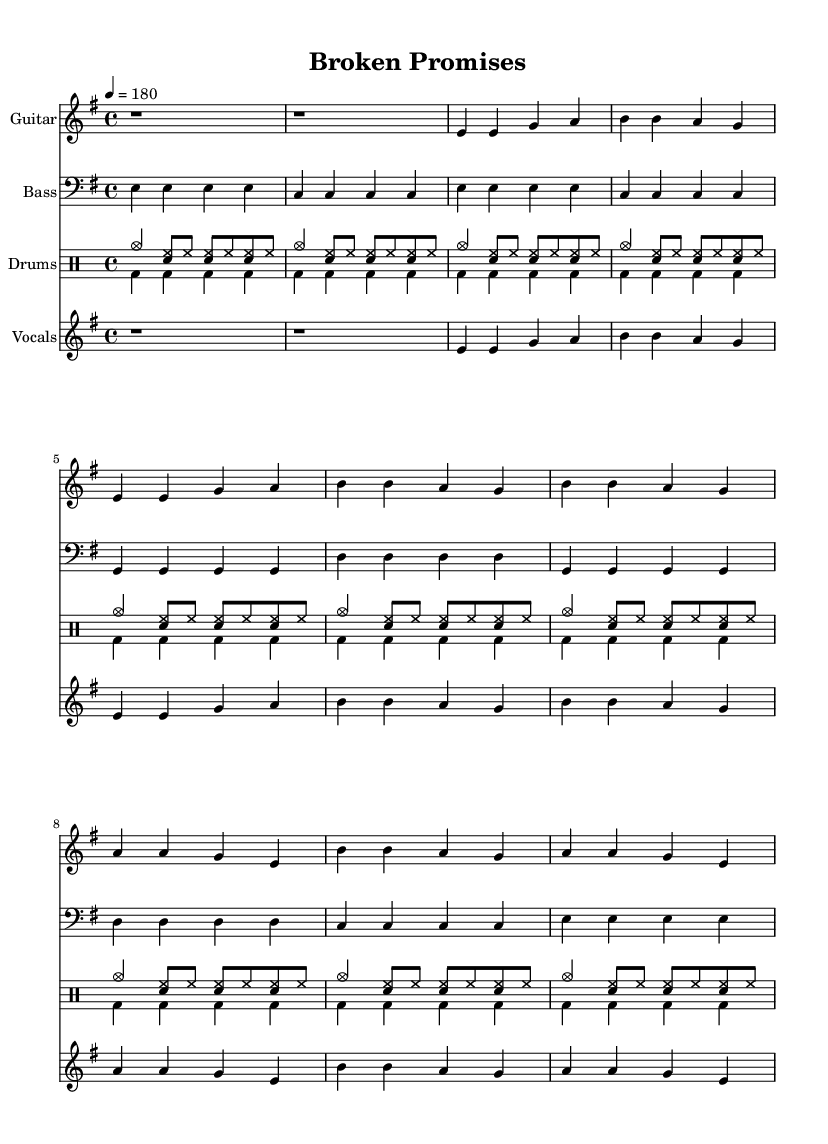What is the key signature of this music? The key signature is indicated at the beginning of the music. We see one sharp (F#), which means it's E minor (also known as G major, which has the same key signature).
Answer: E minor What is the time signature of the song? The time signature is located at the beginning of the piece. It shows "4/4," which means there are four beats in a measure and the quarter note receives one beat.
Answer: 4/4 What is the tempo marking for this piece? The tempo is indicated near the beginning of the music and shows "4 = 180," which indicates that the quarter note is played at 180 beats per minute.
Answer: 180 How many beats are there in the first measure of the guitar part? The first measure of the guitar part shows "r1," which signifies a rest for one whole note, equal to four beats in this context.
Answer: 4 What instrument is playing the music? The music has specific staffs labeled with instrument names. The top staff is labeled as "Guitar," confirming that the guitar is the instrument for that part.
Answer: Guitar What recurring theme is evident in the song's lyrics? Analyzing the lyrics provided in the sheet music, there is a clear focus on struggles related to social inequality and the immigrant experience, as seen through phrases like "Broken promises" and "Fighting for equality."
Answer: Social inequality 